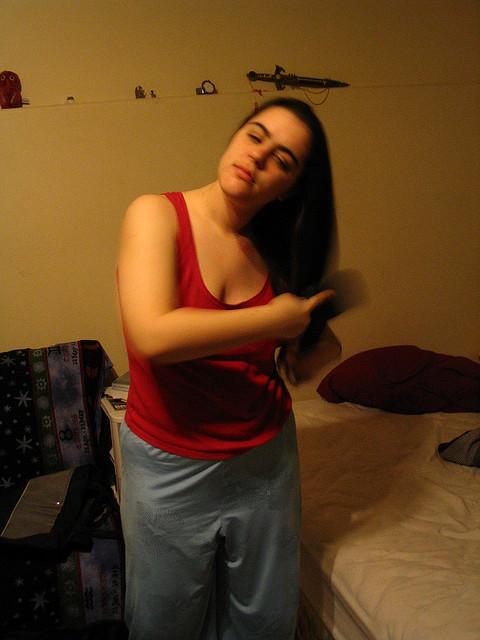What gender is the person?
Keep it brief. Female. What kind of wall treatment is behind the girl?
Short answer required. Stickers. What position is she in?
Short answer required. Standing. Is the woman hot?
Quick response, please. No. What do you call this person?
Quick response, please. Woman. What are these brushes used for?
Answer briefly. Hair. Is she unhappy?
Keep it brief. No. What is holding the girls hair out of her face?
Concise answer only. Brush. What color is the wall?
Concise answer only. White. Is the woman going to bed?
Give a very brief answer. Yes. What's she holding?
Keep it brief. Brush. Is this person married?
Keep it brief. No. What action is this person doing?
Give a very brief answer. Brushing hair. Is the computer covering the lady's face?
Write a very short answer. No. What is the person doing?
Be succinct. Brushing hair. What is she doing?
Answer briefly. Brushing hair. Is this lady getting ready to go clubbing?
Write a very short answer. No. How many people are shown?
Concise answer only. 1. Is the girl wearing a summer dress?
Concise answer only. No. Is she wearing gloves?
Quick response, please. No. What is the person wearing as bottoms?
Give a very brief answer. Pajamas. Is this an adult?
Short answer required. Yes. Is the woman attractive?
Give a very brief answer. Yes. What color is the women's pants?
Quick response, please. Blue. Does she enjoy brushing her hair?
Answer briefly. Yes. What is behind the woman?
Quick response, please. Wall. Is the photo monochromatic?
Quick response, please. No. What color is her shirt?
Quick response, please. Red. Is this girl a model?
Concise answer only. No. What ethnicity is this woman?
Quick response, please. White. Are they eating a snack?
Be succinct. No. What animal is in the picture?
Quick response, please. None. Is this woman pretty?
Give a very brief answer. No. What is the girl thinking of?
Quick response, please. Hair. What material is the girls outfit made from?
Keep it brief. Cotton. How many people in the picture?
Answer briefly. 1. Is the kneeling on the grass?
Quick response, please. No. What color are the woman's pants?
Give a very brief answer. Blue. Is the person wearing jeans?
Quick response, please. No. What is this person doing?
Keep it brief. Brushing hair. What color is the woman's hair?
Concise answer only. Brown. Is this girl or a boy?
Give a very brief answer. Girl. Why is the girl standing in the middle of the room with an object in each hand?
Be succinct. Brushing hair. What color is the instrument in the background?
Give a very brief answer. Black. Is this outdoors?
Keep it brief. No. What is the person standing by?
Keep it brief. Bed. Is the woman married?
Be succinct. No. What is the female standing on?
Be succinct. Floor. Is the woman curling her hair?
Keep it brief. No. Does the person in the red shirt have a backpack on?
Short answer required. No. Is this person standing up?
Be succinct. Yes. What color is her blouse?
Answer briefly. Red. What room is she in?
Answer briefly. Bedroom. What kind of pants is the standing person wearing?
Keep it brief. Scrubs. Is the woman wearing a dress?
Answer briefly. No. What color is the girl's pants?
Quick response, please. Blue. Is the woman cold?
Concise answer only. No. Where is the face looking?
Concise answer only. At camera. What is the woman holding?
Give a very brief answer. Brush. 